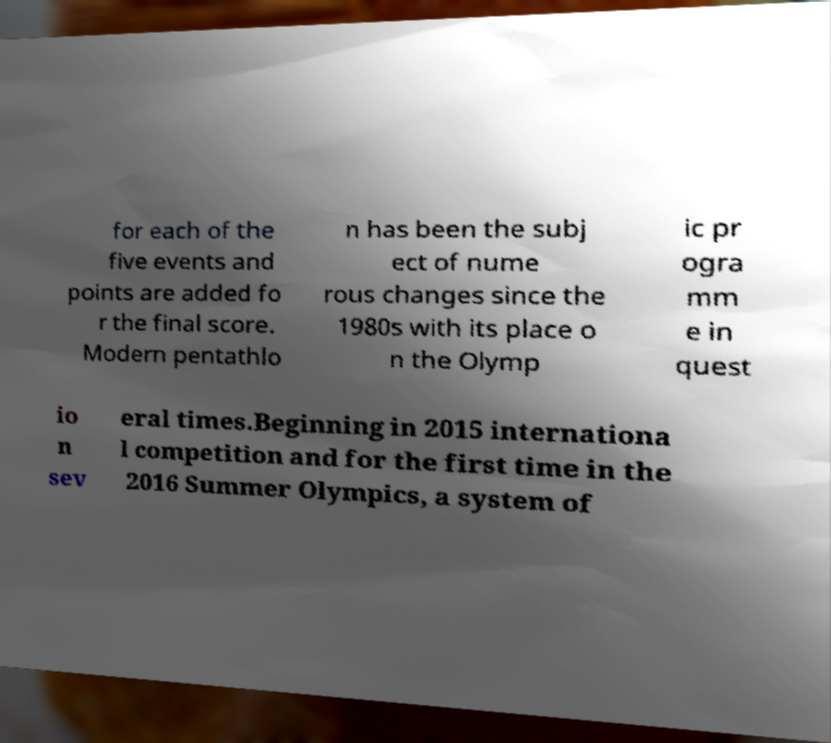There's text embedded in this image that I need extracted. Can you transcribe it verbatim? for each of the five events and points are added fo r the final score. Modern pentathlo n has been the subj ect of nume rous changes since the 1980s with its place o n the Olymp ic pr ogra mm e in quest io n sev eral times.Beginning in 2015 internationa l competition and for the first time in the 2016 Summer Olympics, a system of 